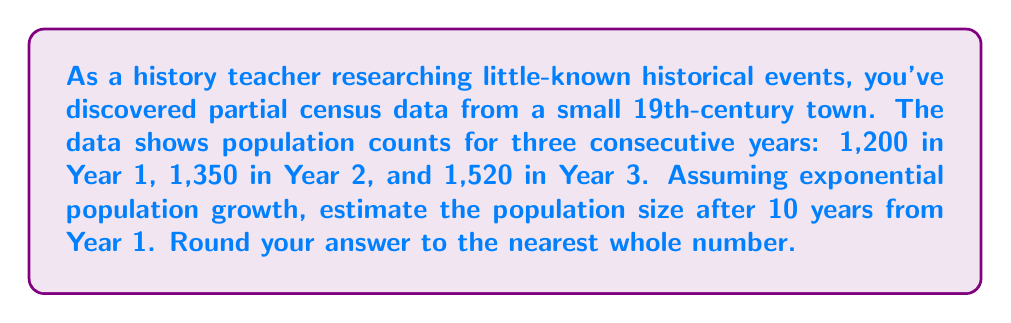Provide a solution to this math problem. To solve this problem, we'll use the exponential growth model and follow these steps:

1) The exponential growth model is given by:
   $$P(t) = P_0 \cdot e^{rt}$$
   where $P(t)$ is the population at time $t$, $P_0$ is the initial population, $r$ is the growth rate, and $t$ is time.

2) We need to find $r$ using the given data. We can use any two consecutive years:
   $$1350 = 1200 \cdot e^r$$
   $$e^r = \frac{1350}{1200} = 1.125$$
   $$r = \ln(1.125) \approx 0.1178$$

3) We can verify this rate using Years 2 and 3:
   $$1520 = 1350 \cdot e^r$$
   $$e^r = \frac{1520}{1350} \approx 1.1259$$
   This confirms our calculated rate is consistent.

4) Now we can use the model to estimate the population after 10 years:
   $$P(10) = 1200 \cdot e^{0.1178 \cdot 10}$$

5) Calculate:
   $$P(10) = 1200 \cdot e^{1.178} \approx 1200 \cdot 3.2478 \approx 3897.36$$

6) Rounding to the nearest whole number:
   $$P(10) \approx 3897$$
Answer: 3897 